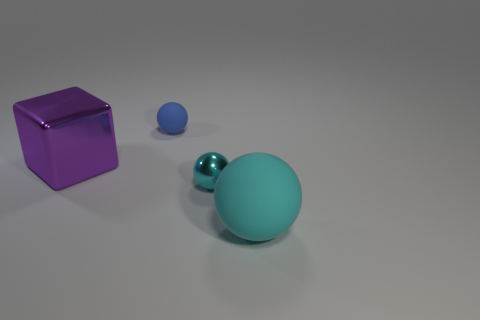What is the shape of the big metal thing?
Provide a short and direct response. Cube. There is a rubber thing that is to the right of the small blue object; is it the same color as the small object that is in front of the blue rubber object?
Keep it short and to the point. Yes. Does the large cyan rubber thing have the same shape as the tiny blue matte object?
Offer a very short reply. Yes. Is there anything else that has the same shape as the big metallic thing?
Offer a very short reply. No. Is the small object behind the large block made of the same material as the big cyan thing?
Ensure brevity in your answer.  Yes. What is the shape of the object that is both to the left of the large matte object and in front of the big purple thing?
Make the answer very short. Sphere. There is a tiny sphere to the left of the small cyan object; are there any big cubes that are on the left side of it?
Your answer should be compact. Yes. How many other objects are there of the same material as the tiny cyan object?
Provide a short and direct response. 1. There is a thing behind the purple thing; is it the same shape as the object right of the small metallic object?
Keep it short and to the point. Yes. Are the big cyan object and the tiny cyan thing made of the same material?
Your response must be concise. No. 